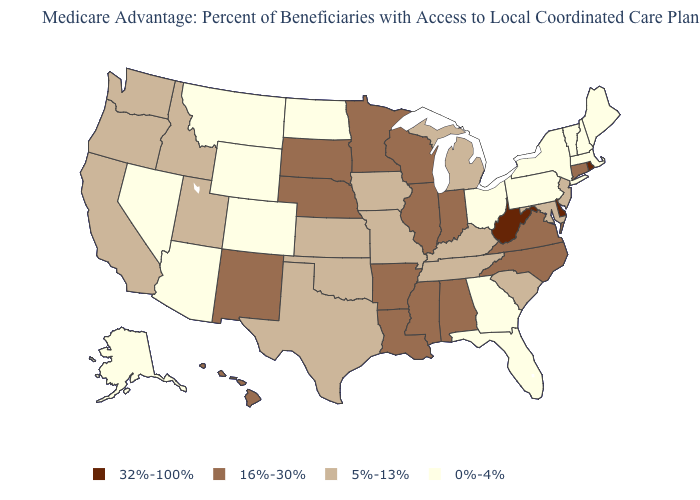Does West Virginia have the highest value in the South?
Give a very brief answer. Yes. Name the states that have a value in the range 5%-13%?
Answer briefly. California, Iowa, Idaho, Kansas, Kentucky, Maryland, Michigan, Missouri, New Jersey, Oklahoma, Oregon, South Carolina, Tennessee, Texas, Utah, Washington. Name the states that have a value in the range 0%-4%?
Quick response, please. Alaska, Arizona, Colorado, Florida, Georgia, Massachusetts, Maine, Montana, North Dakota, New Hampshire, Nevada, New York, Ohio, Pennsylvania, Vermont, Wyoming. What is the highest value in the MidWest ?
Quick response, please. 16%-30%. Which states have the lowest value in the USA?
Answer briefly. Alaska, Arizona, Colorado, Florida, Georgia, Massachusetts, Maine, Montana, North Dakota, New Hampshire, Nevada, New York, Ohio, Pennsylvania, Vermont, Wyoming. Does Maine have the lowest value in the USA?
Write a very short answer. Yes. What is the lowest value in the MidWest?
Quick response, please. 0%-4%. Does the map have missing data?
Answer briefly. No. Name the states that have a value in the range 5%-13%?
Give a very brief answer. California, Iowa, Idaho, Kansas, Kentucky, Maryland, Michigan, Missouri, New Jersey, Oklahoma, Oregon, South Carolina, Tennessee, Texas, Utah, Washington. Which states have the lowest value in the USA?
Give a very brief answer. Alaska, Arizona, Colorado, Florida, Georgia, Massachusetts, Maine, Montana, North Dakota, New Hampshire, Nevada, New York, Ohio, Pennsylvania, Vermont, Wyoming. Does Florida have the lowest value in the South?
Be succinct. Yes. Is the legend a continuous bar?
Short answer required. No. Name the states that have a value in the range 32%-100%?
Give a very brief answer. Delaware, Rhode Island, West Virginia. What is the value of North Dakota?
Write a very short answer. 0%-4%. What is the value of Virginia?
Short answer required. 16%-30%. 